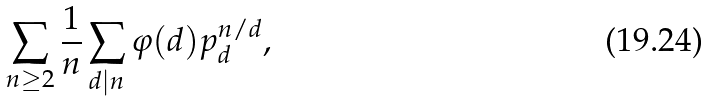<formula> <loc_0><loc_0><loc_500><loc_500>\sum _ { n \geq 2 } \frac { 1 } { n } \sum _ { d | n } \varphi ( d ) p _ { d } ^ { n / d } ,</formula> 